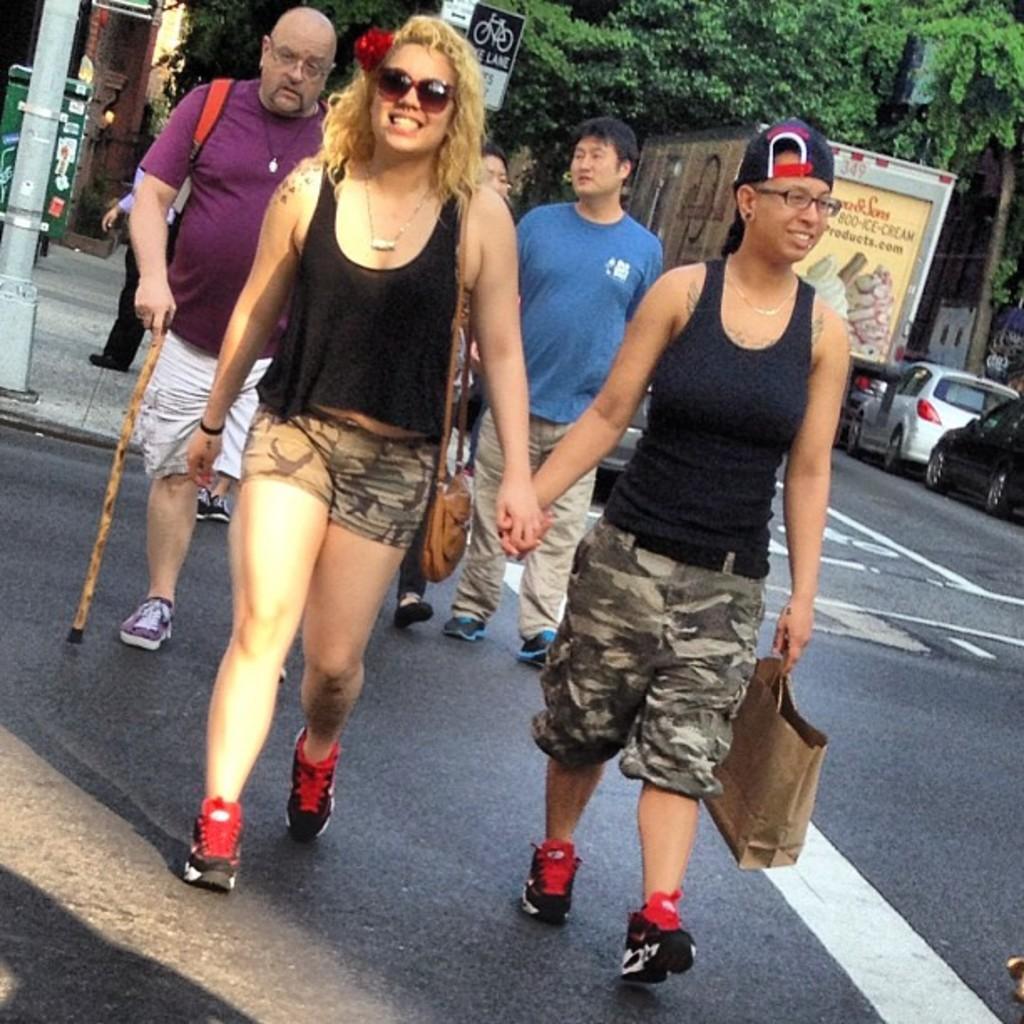Describe this image in one or two sentences. In this image we can see the people walking on the road and holding a bag and stick. In the background, we can see the vehicles on the road and there are trees, sign board, box, pole and few objects. 